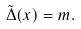<formula> <loc_0><loc_0><loc_500><loc_500>\tilde { \Delta } ( x ) = m .</formula> 